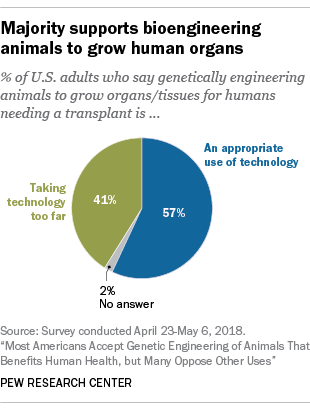Specify some key components in this picture. The average value of all three segments of the graph is 33.3. The smallest segment of the graph is gray. 